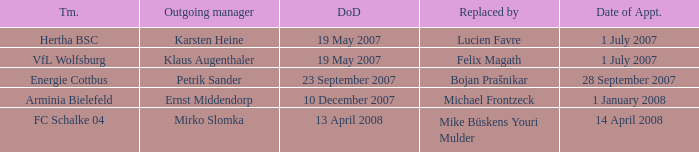When is the appointment date for outgoing manager Petrik Sander? 28 September 2007. 